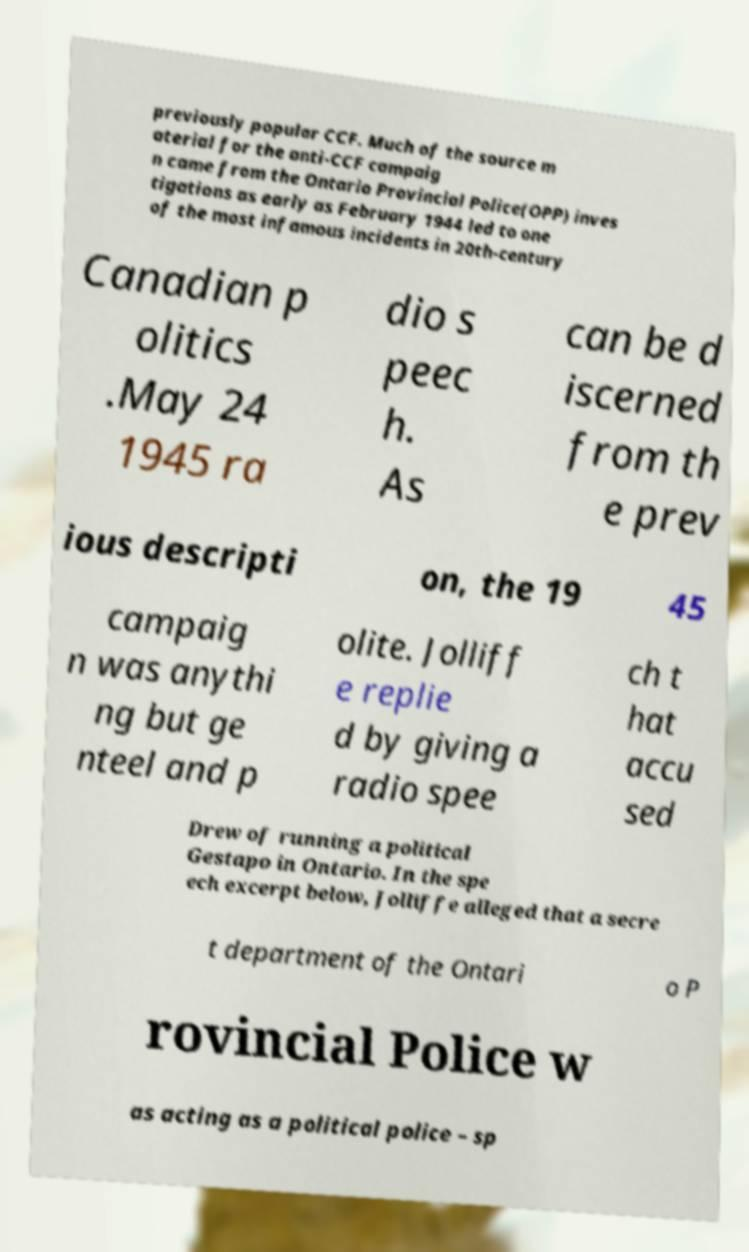Could you assist in decoding the text presented in this image and type it out clearly? previously popular CCF. Much of the source m aterial for the anti-CCF campaig n came from the Ontario Provincial Police(OPP) inves tigations as early as February 1944 led to one of the most infamous incidents in 20th-century Canadian p olitics .May 24 1945 ra dio s peec h. As can be d iscerned from th e prev ious descripti on, the 19 45 campaig n was anythi ng but ge nteel and p olite. Jolliff e replie d by giving a radio spee ch t hat accu sed Drew of running a political Gestapo in Ontario. In the spe ech excerpt below, Jolliffe alleged that a secre t department of the Ontari o P rovincial Police w as acting as a political police – sp 